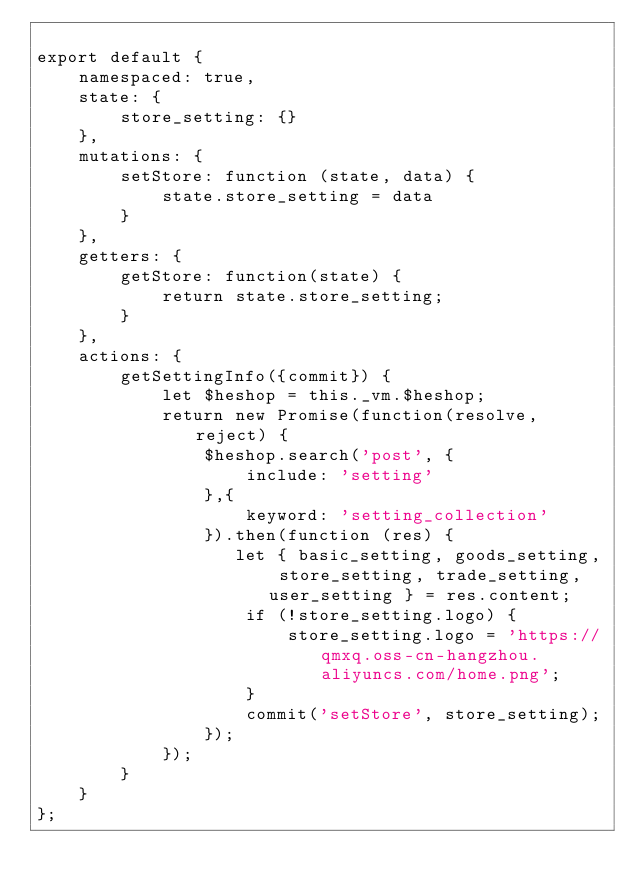Convert code to text. <code><loc_0><loc_0><loc_500><loc_500><_JavaScript_>
export default {
    namespaced: true,
    state: {
        store_setting: {}
    },
    mutations: {
        setStore: function (state, data) {
            state.store_setting = data
        }
    },
    getters: {
        getStore: function(state) {
            return state.store_setting;
        }
    },
    actions: {
        getSettingInfo({commit}) {
            let $heshop = this._vm.$heshop;
            return new Promise(function(resolve, reject) {
                $heshop.search('post', {
                    include: 'setting'
                },{
                    keyword: 'setting_collection'
                }).then(function (res) {
                   let { basic_setting, goods_setting, store_setting, trade_setting, user_setting } = res.content;
                    if (!store_setting.logo) {
                        store_setting.logo = 'https://qmxq.oss-cn-hangzhou.aliyuncs.com/home.png';
                    }
                    commit('setStore', store_setting);
                });
            });
        }
    }
};
</code> 